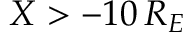<formula> <loc_0><loc_0><loc_500><loc_500>X > - 1 0 \, R _ { E }</formula> 